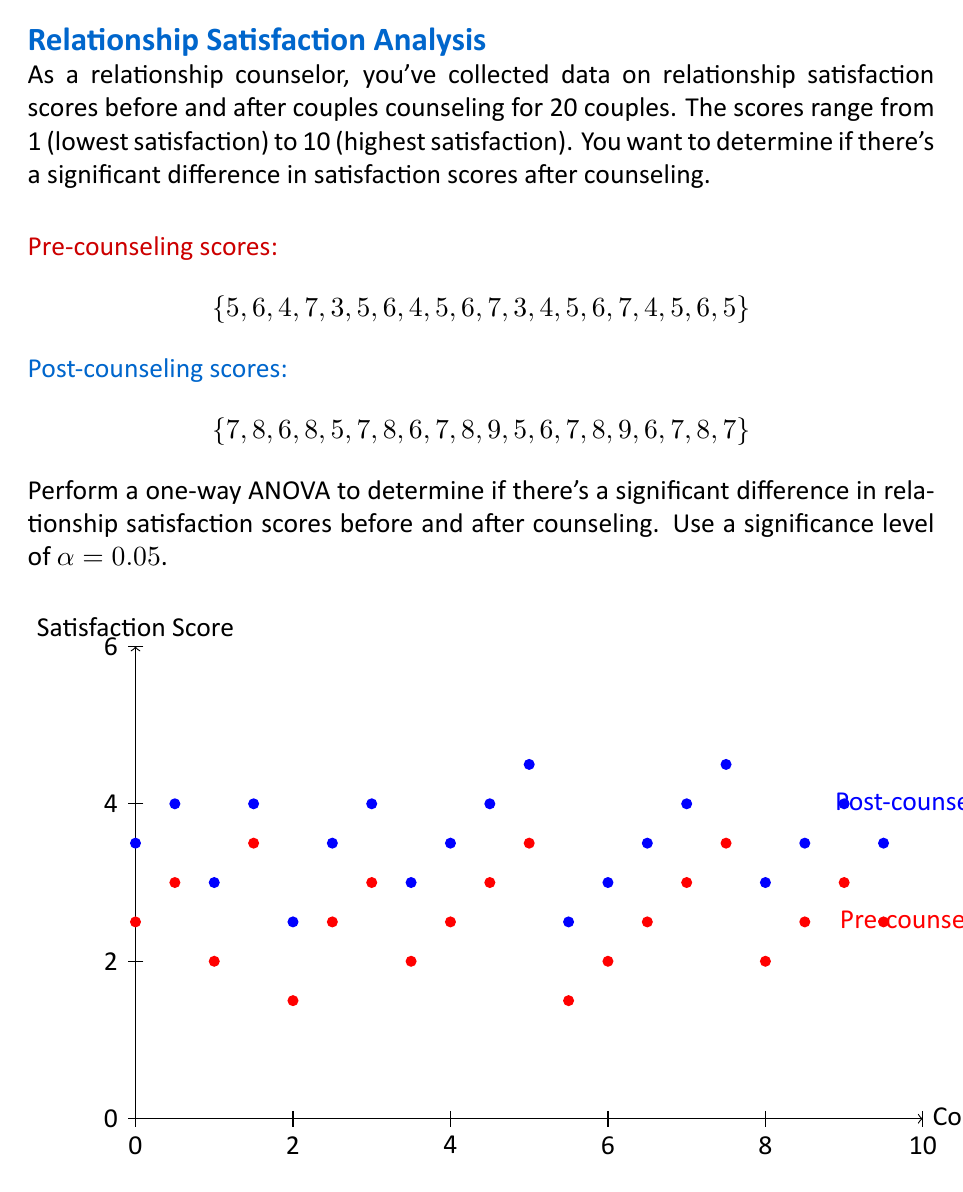Solve this math problem. To perform a one-way ANOVA, we'll follow these steps:

1. Calculate the sum of squares between groups (SSB) and within groups (SSW).
2. Calculate the degrees of freedom for between groups (dfB) and within groups (dfW).
3. Calculate the mean squares between groups (MSB) and within groups (MSW).
4. Calculate the F-statistic.
5. Compare the F-statistic to the critical F-value.

Step 1: Calculate SSB and SSW

First, we need to calculate the grand mean:
$$\bar{X} = \frac{\sum_{i=1}^{40} X_i}{40} = \frac{252}{40} = 6.3$$

Now, calculate SSB:
$$SSB = n_1(\bar{X_1} - \bar{X})^2 + n_2(\bar{X_2} - \bar{X})^2$$
$$SSB = 20(5.15 - 6.3)^2 + 20(7.45 - 6.3)^2 = 52.9$$

For SSW, we calculate the sum of squared deviations within each group:
$$SSW = \sum_{i=1}^{20} (X_{1i} - \bar{X_1})^2 + \sum_{i=1}^{20} (X_{2i} - \bar{X_2})^2 = 38.7$$

Step 2: Calculate degrees of freedom

$$df_B = k - 1 = 2 - 1 = 1$$
$$df_W = N - k = 40 - 2 = 38$$

Where k is the number of groups and N is the total number of observations.

Step 3: Calculate mean squares

$$MSB = \frac{SSB}{df_B} = \frac{52.9}{1} = 52.9$$
$$MSW = \frac{SSW}{df_W} = \frac{38.7}{38} = 1.018$$

Step 4: Calculate F-statistic

$$F = \frac{MSB}{MSW} = \frac{52.9}{1.018} = 51.96$$

Step 5: Compare to critical F-value

The critical F-value for α = 0.05, df_B = 1, and df_W = 38 is approximately 4.10.

Since our calculated F-statistic (51.96) is greater than the critical F-value (4.10), we reject the null hypothesis.
Answer: Reject null hypothesis; significant difference in satisfaction scores (F(1,38) = 51.96, p < 0.05) 